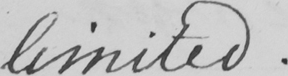Can you read and transcribe this handwriting? limited . 